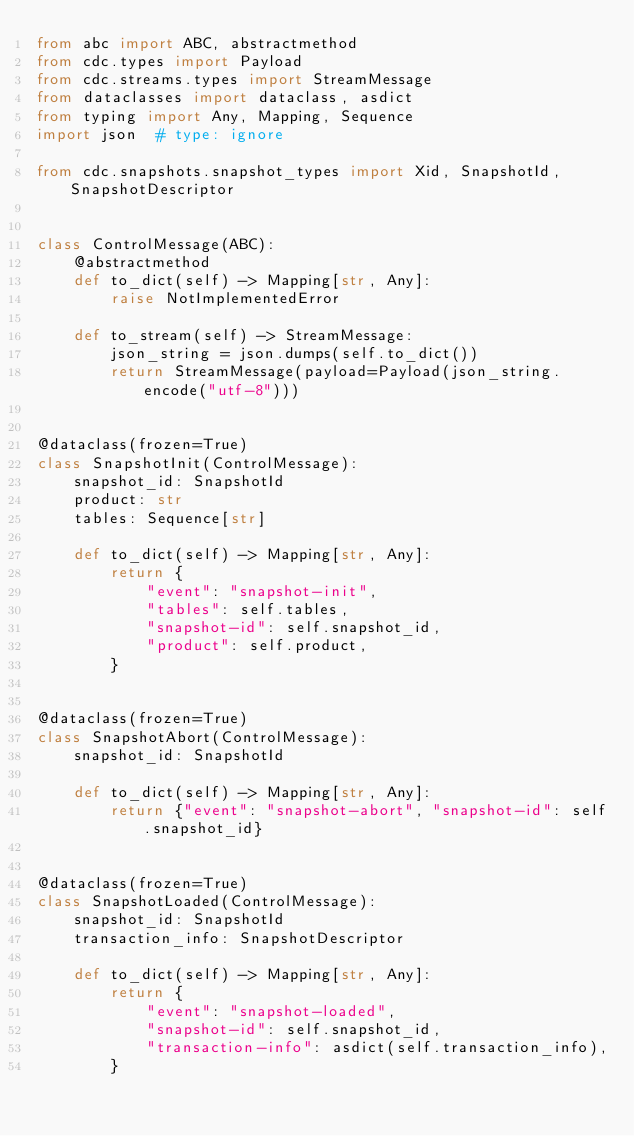<code> <loc_0><loc_0><loc_500><loc_500><_Python_>from abc import ABC, abstractmethod
from cdc.types import Payload
from cdc.streams.types import StreamMessage
from dataclasses import dataclass, asdict
from typing import Any, Mapping, Sequence
import json  # type: ignore

from cdc.snapshots.snapshot_types import Xid, SnapshotId, SnapshotDescriptor


class ControlMessage(ABC):
    @abstractmethod
    def to_dict(self) -> Mapping[str, Any]:
        raise NotImplementedError

    def to_stream(self) -> StreamMessage:
        json_string = json.dumps(self.to_dict())
        return StreamMessage(payload=Payload(json_string.encode("utf-8")))


@dataclass(frozen=True)
class SnapshotInit(ControlMessage):
    snapshot_id: SnapshotId
    product: str
    tables: Sequence[str]

    def to_dict(self) -> Mapping[str, Any]:
        return {
            "event": "snapshot-init",
            "tables": self.tables,
            "snapshot-id": self.snapshot_id,
            "product": self.product,
        }


@dataclass(frozen=True)
class SnapshotAbort(ControlMessage):
    snapshot_id: SnapshotId

    def to_dict(self) -> Mapping[str, Any]:
        return {"event": "snapshot-abort", "snapshot-id": self.snapshot_id}


@dataclass(frozen=True)
class SnapshotLoaded(ControlMessage):
    snapshot_id: SnapshotId
    transaction_info: SnapshotDescriptor

    def to_dict(self) -> Mapping[str, Any]:
        return {
            "event": "snapshot-loaded",
            "snapshot-id": self.snapshot_id,
            "transaction-info": asdict(self.transaction_info),
        }
</code> 